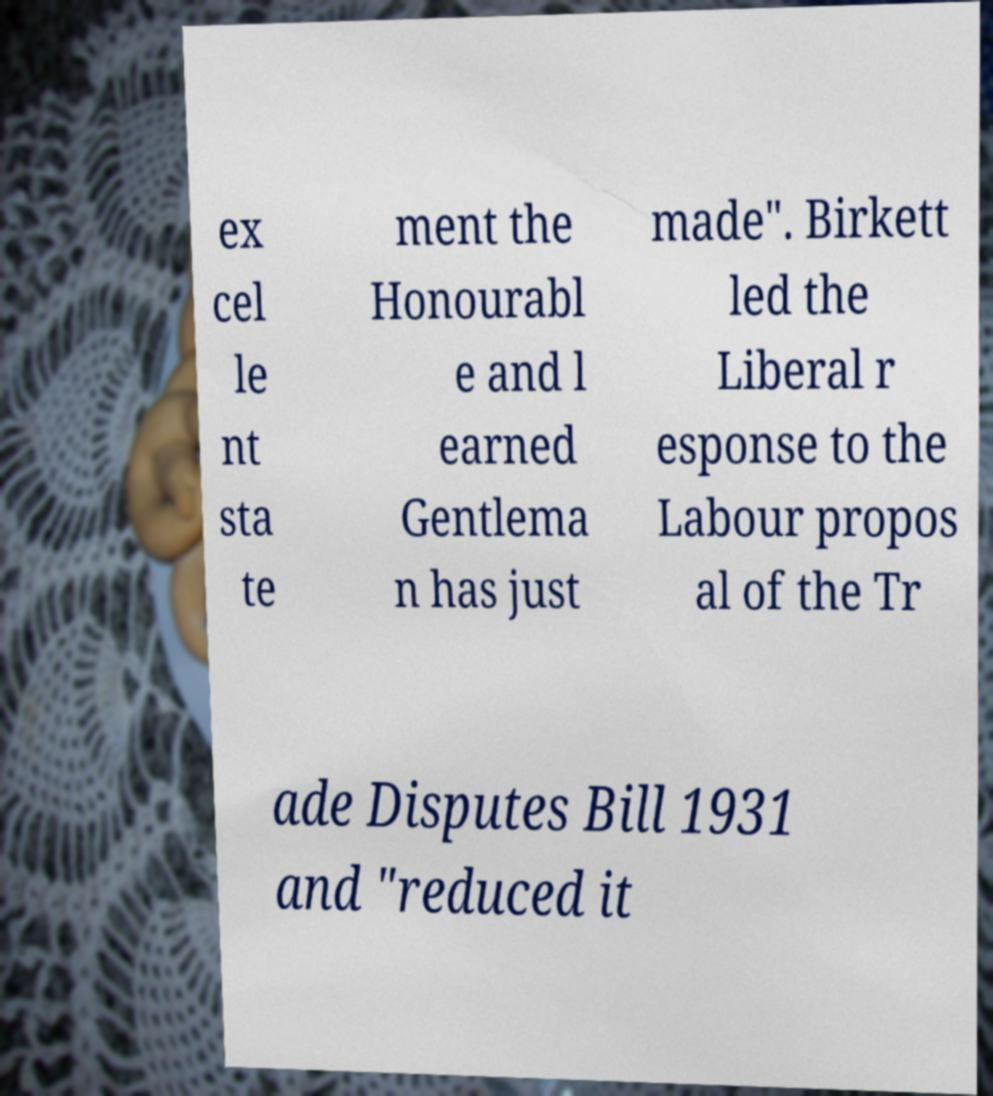There's text embedded in this image that I need extracted. Can you transcribe it verbatim? ex cel le nt sta te ment the Honourabl e and l earned Gentlema n has just made". Birkett led the Liberal r esponse to the Labour propos al of the Tr ade Disputes Bill 1931 and "reduced it 